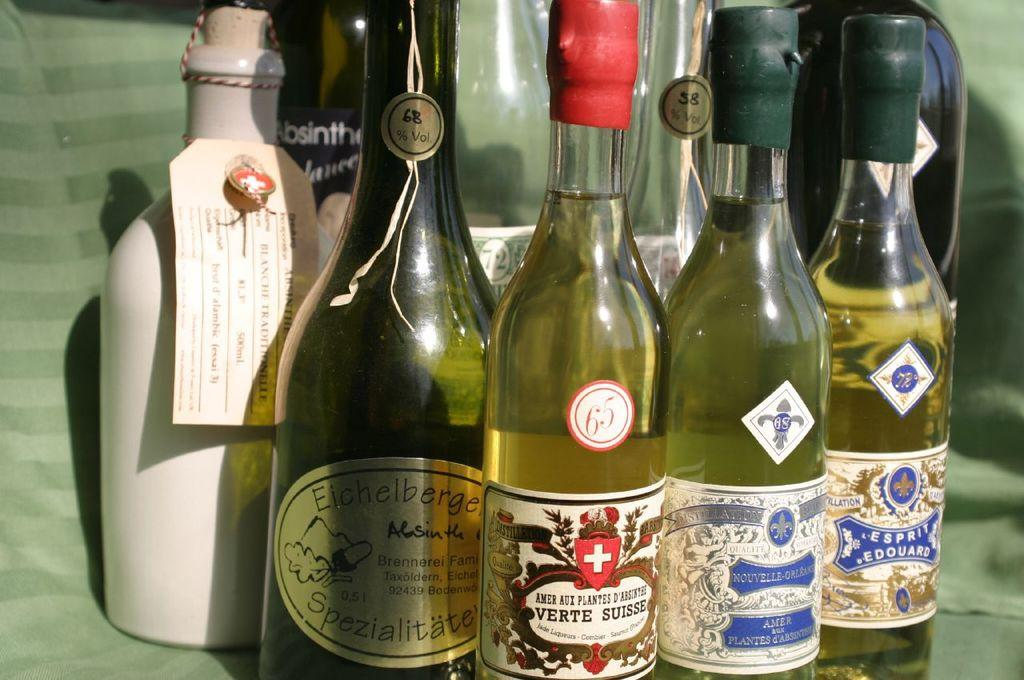<image>
Relay a brief, clear account of the picture shown. the word verte is on the front of a bottle 